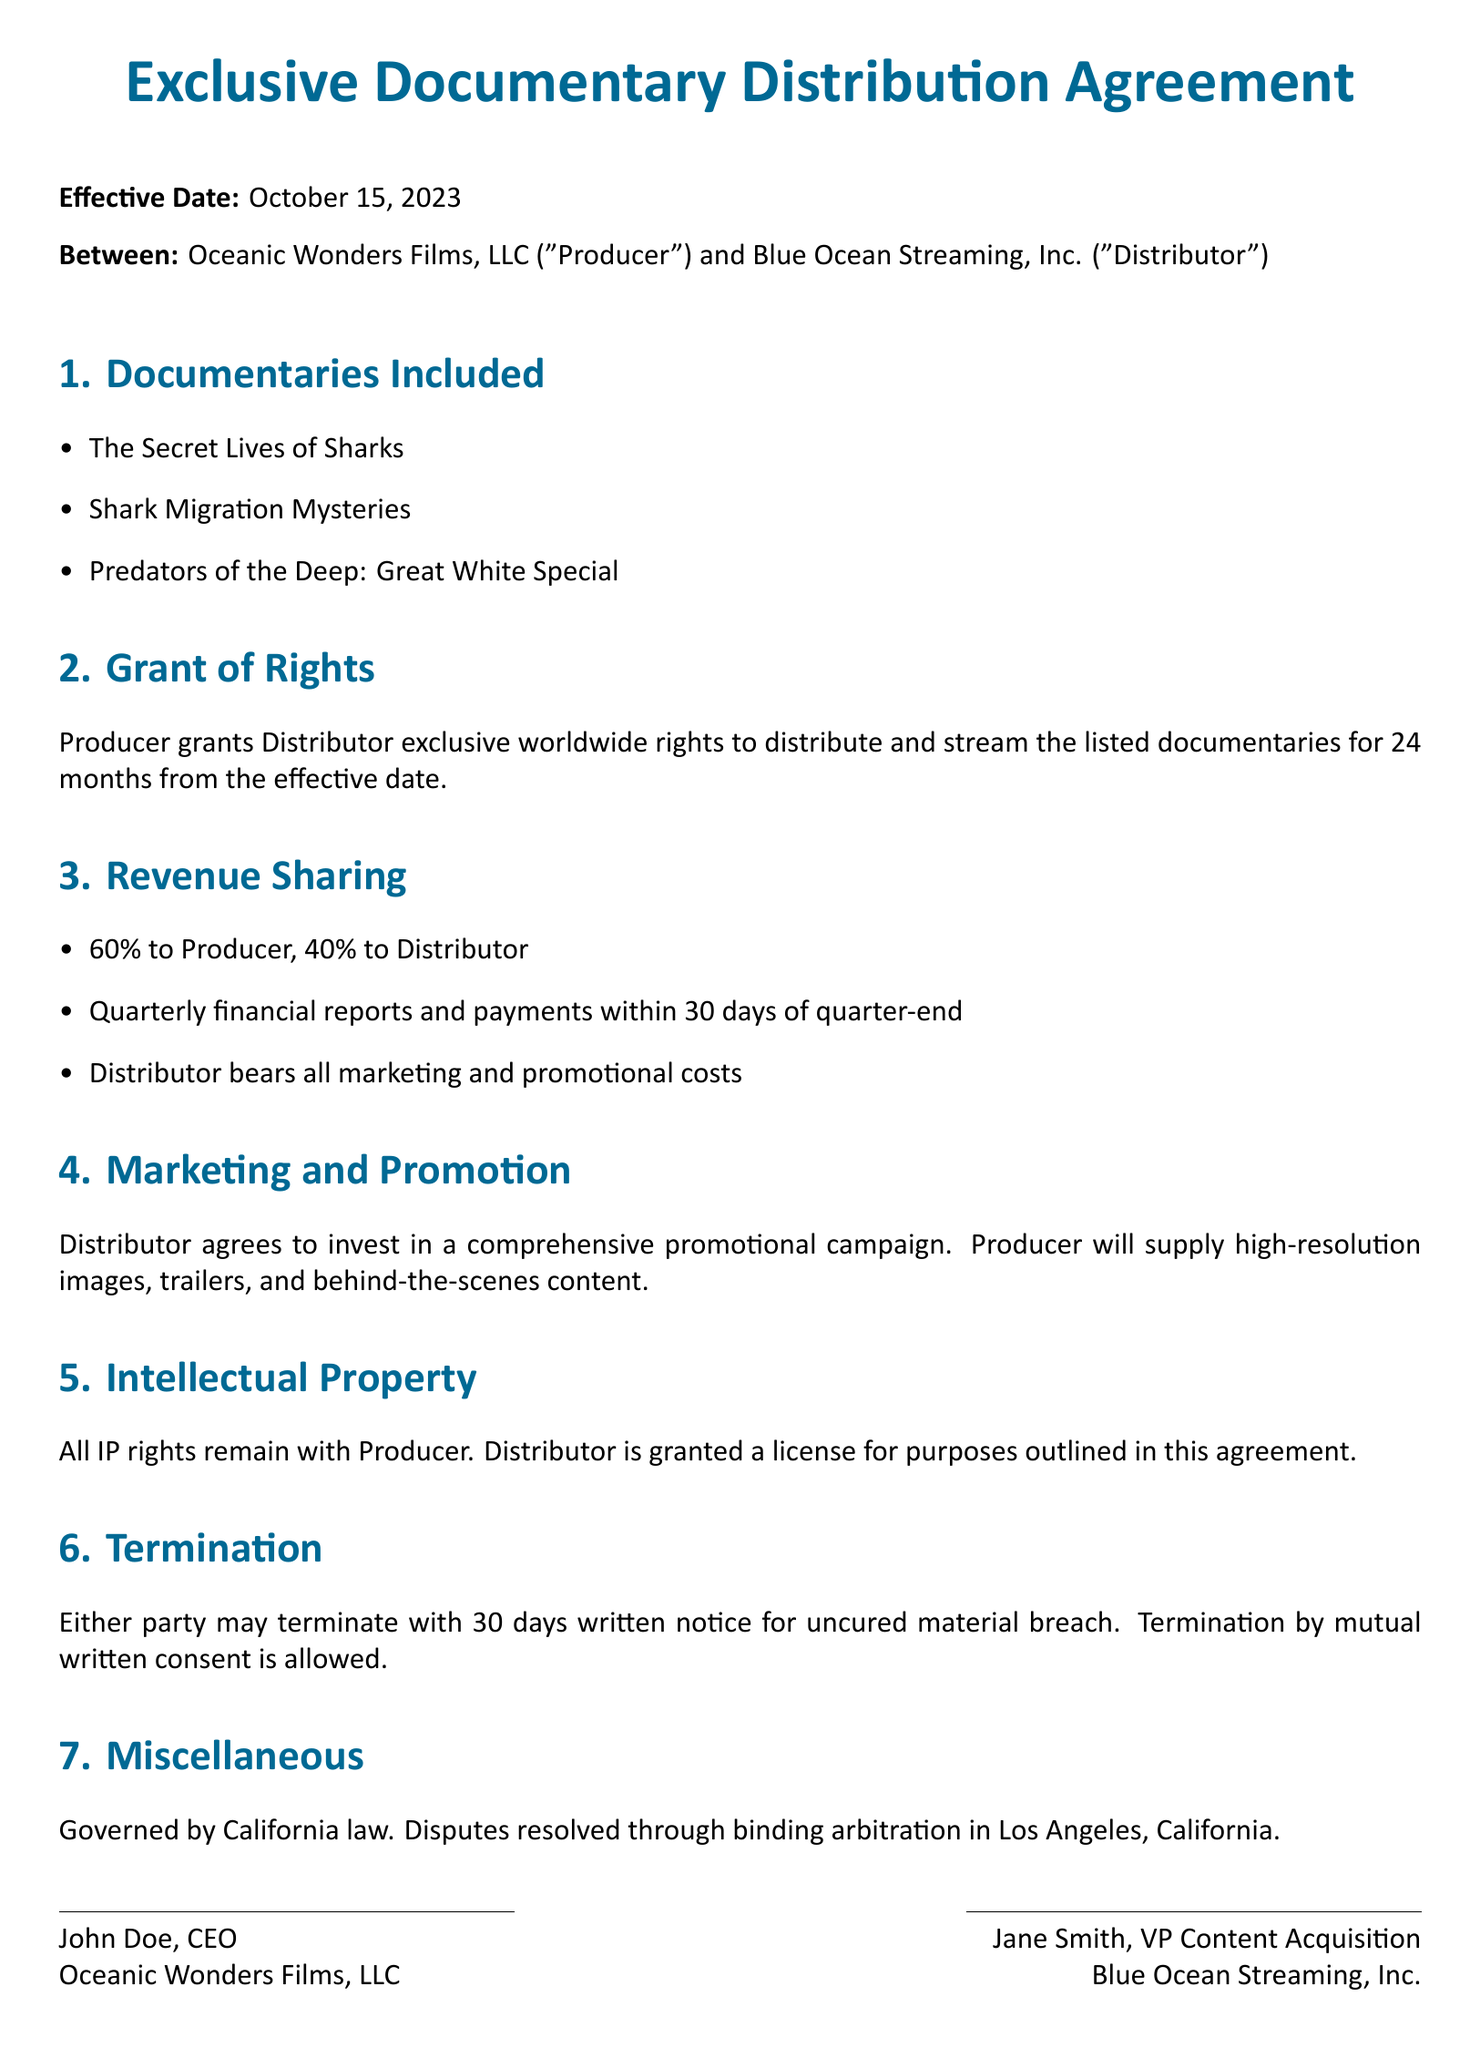What is the effective date of the agreement? The effective date is stated at the beginning of the document.
Answer: October 15, 2023 Who is the Producer in the agreement? The name of the Producer is mentioned right after the effective date.
Answer: Oceanic Wonders Films, LLC What is the revenue share percentage for the Producer? The revenue sharing details are listed under the Revenue Sharing section.
Answer: 60% For how long is the distribution agreement valid? The duration of the agreement is specified in the Grant of Rights section.
Answer: 24 months What will the Distributor bear all costs for? This information is found in the Revenue Sharing section.
Answer: Marketing and promotional costs What type of rights are granted to the Distributor? The type of rights granted is discussed in the Grant of Rights section.
Answer: Exclusive worldwide rights How many documentaries are included in the agreement? The number of included documentaries is listed in the Documentaries Included section.
Answer: Three What governing law applies to the agreement? The governing law is mentioned in the Miscellaneous section.
Answer: California law What is the required notice period for termination? This detail is outlined in the Termination section.
Answer: 30 days 